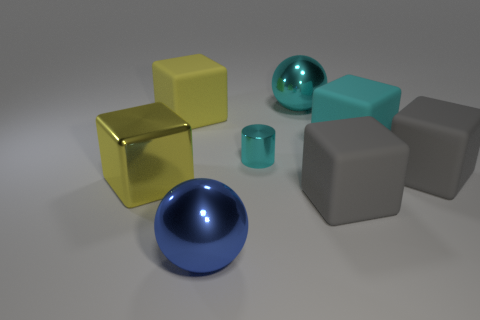Subtract all gray rubber blocks. How many blocks are left? 3 Add 1 big yellow metallic objects. How many objects exist? 9 Subtract all cyan balls. How many balls are left? 1 Subtract 4 blocks. How many blocks are left? 1 Subtract all big yellow matte objects. Subtract all metallic objects. How many objects are left? 3 Add 4 shiny blocks. How many shiny blocks are left? 5 Add 7 blue shiny balls. How many blue shiny balls exist? 8 Subtract 0 purple cylinders. How many objects are left? 8 Subtract all cylinders. How many objects are left? 7 Subtract all green spheres. Subtract all red cylinders. How many spheres are left? 2 